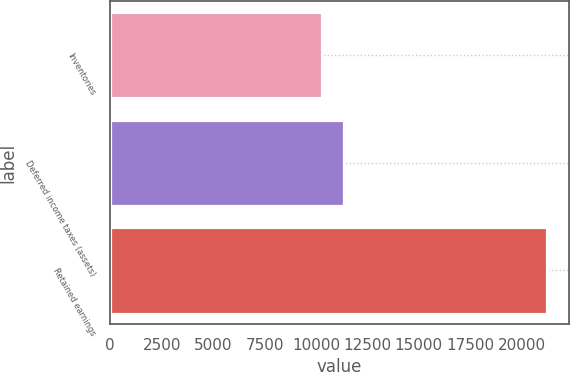Convert chart. <chart><loc_0><loc_0><loc_500><loc_500><bar_chart><fcel>Inventories<fcel>Deferred income taxes (assets)<fcel>Retained earnings<nl><fcel>10277<fcel>11371.1<fcel>21218<nl></chart> 